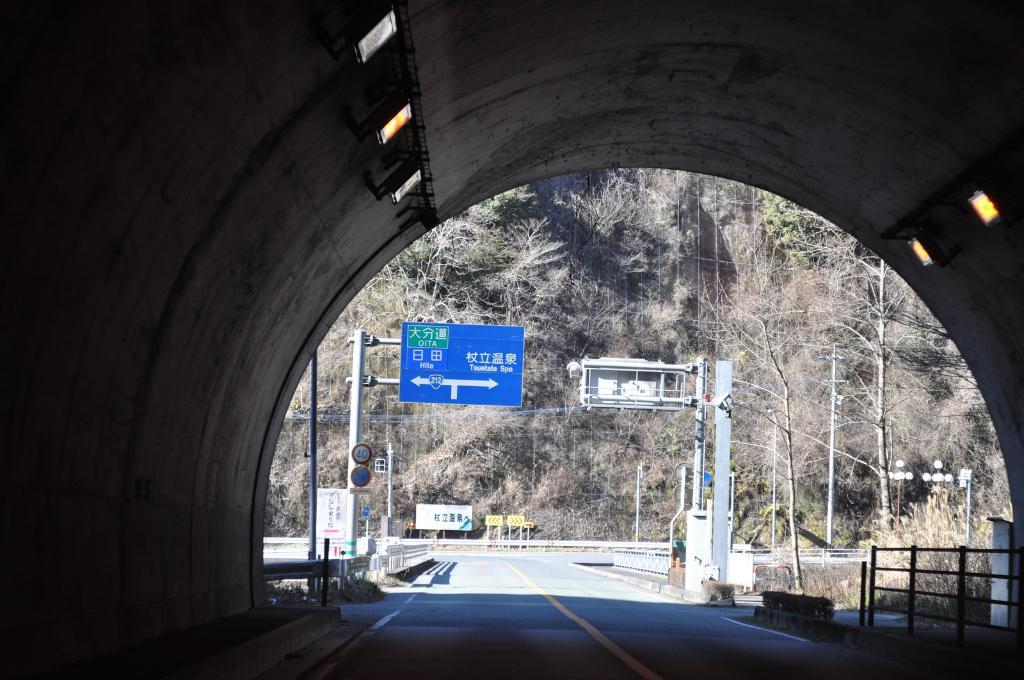What is the location from which the image was taken? The image is taken from a tunnel. What can be seen in the center of the picture? There are sign boards, plants, and a railing in the center of the picture. What is visible in the background of the picture? There are trees, a hill, a sign board, and poles in the background of the picture. What is the weight of the observation tower in the image? There is no observation tower present in the image, so it is not possible to determine its weight. 